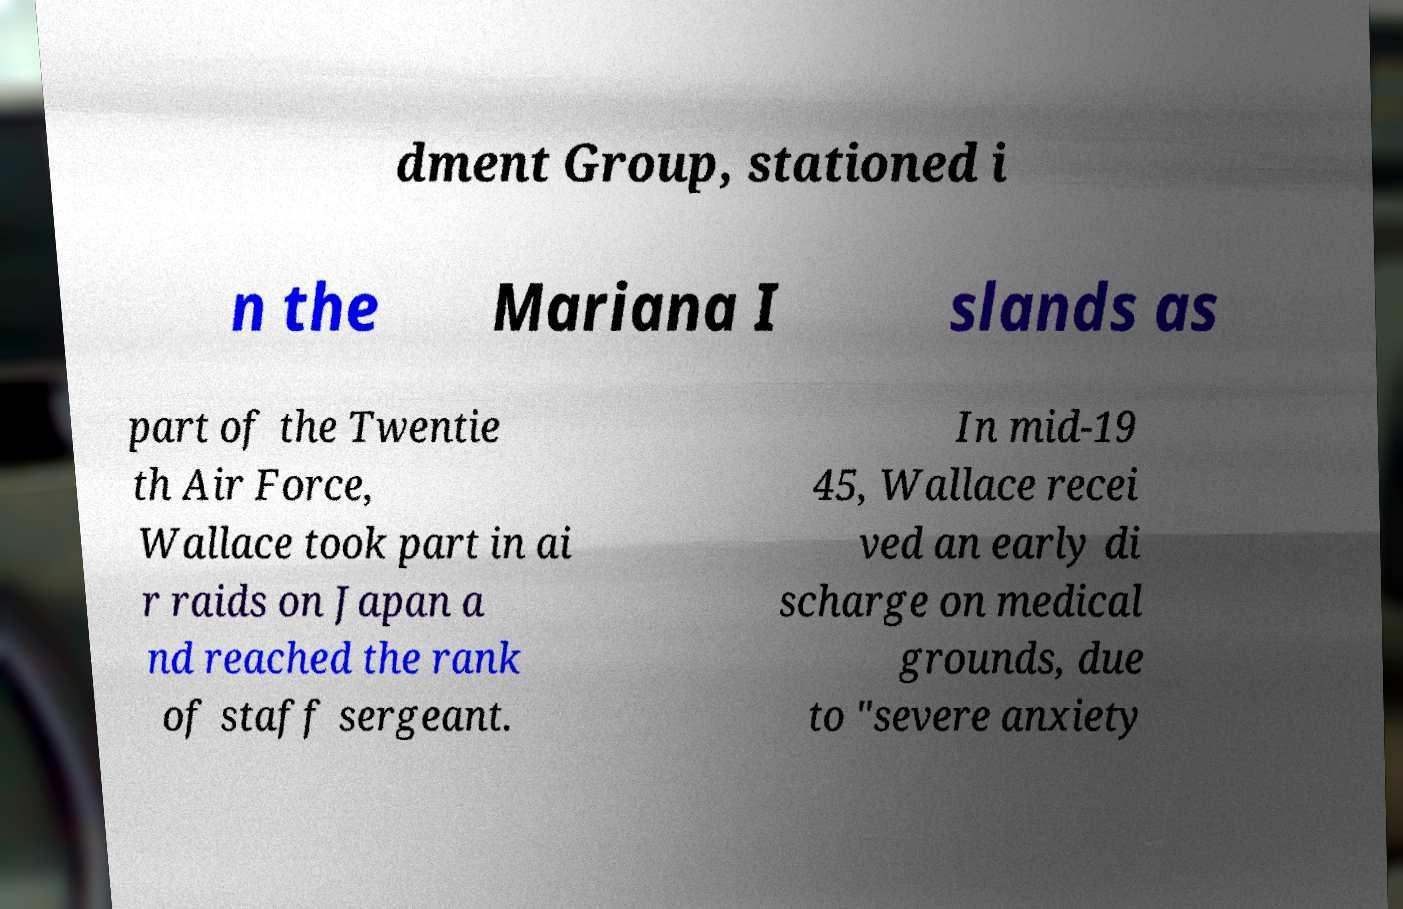Could you extract and type out the text from this image? dment Group, stationed i n the Mariana I slands as part of the Twentie th Air Force, Wallace took part in ai r raids on Japan a nd reached the rank of staff sergeant. In mid-19 45, Wallace recei ved an early di scharge on medical grounds, due to "severe anxiety 